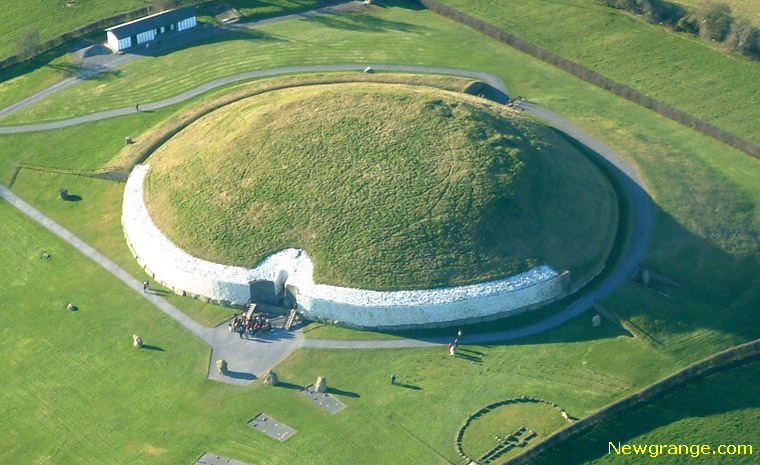Describe the following image. The image captures the spectacular Newgrange monument located in Ireland, an ancient marvel built over 5,000 years ago. Dominating the scene is a large circular mound with a meticulously arranged white stone wall around its base, highlighting its grand structure. The mound is cloaked in lush green grass, offering a striking contrast to the white stones. A prominent entrance is visible, inviting one to ponder the mysteries hidden within. The verdant landscape surrounding Newgrange extends expansively, with modern buildings and roads interspersed, coexisting harmoniously with this ancient wonder. This aerial perspective affords a comprehensive view of the monument's grandeur and its serene integration with the environment. The image beautifully marries history with nature, reflecting on a landmark that has both endured and enchanted through millennia. 